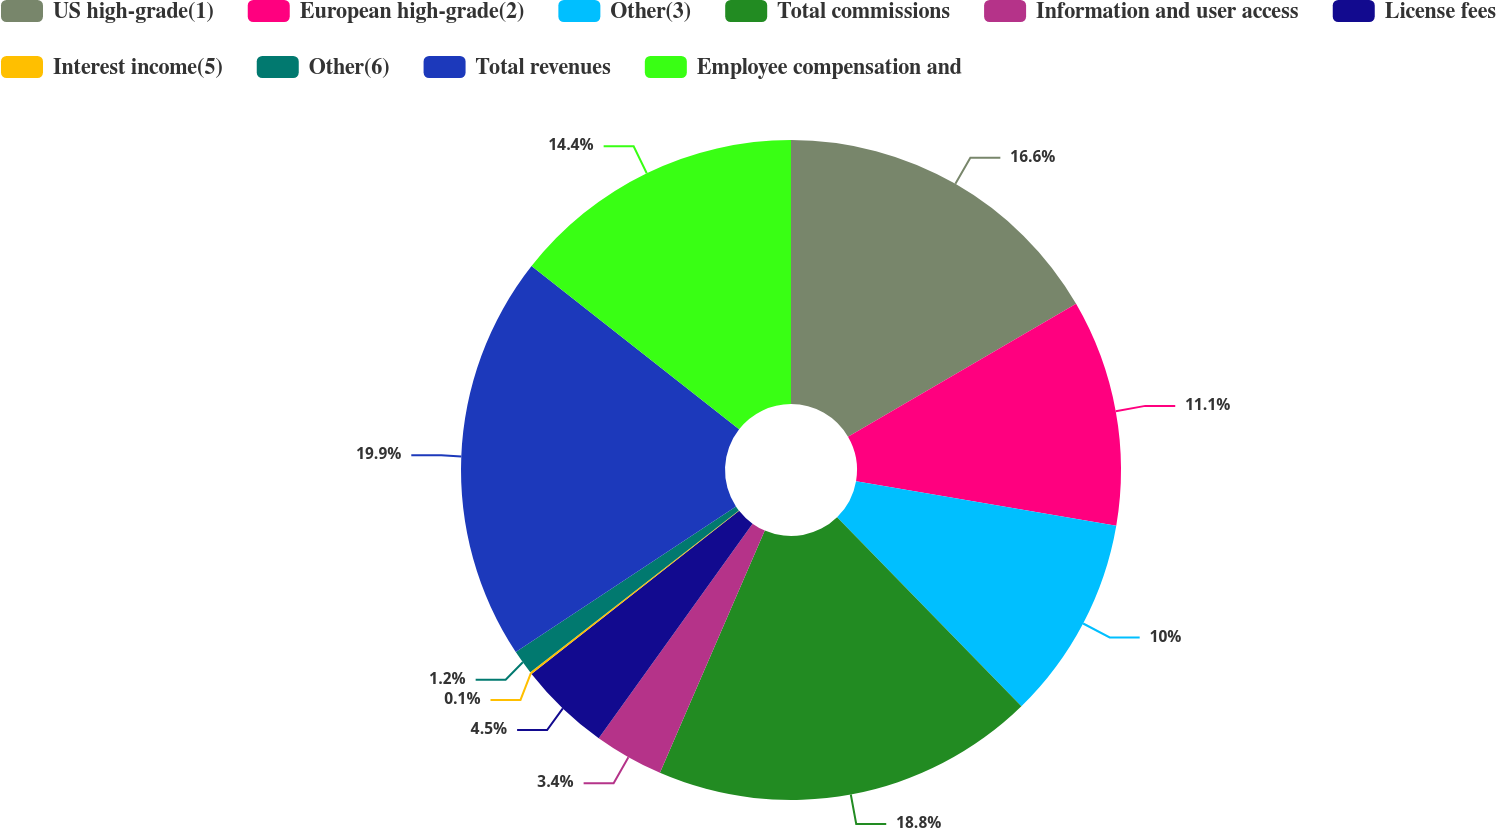Convert chart to OTSL. <chart><loc_0><loc_0><loc_500><loc_500><pie_chart><fcel>US high-grade(1)<fcel>European high-grade(2)<fcel>Other(3)<fcel>Total commissions<fcel>Information and user access<fcel>License fees<fcel>Interest income(5)<fcel>Other(6)<fcel>Total revenues<fcel>Employee compensation and<nl><fcel>16.6%<fcel>11.1%<fcel>10.0%<fcel>18.8%<fcel>3.4%<fcel>4.5%<fcel>0.1%<fcel>1.2%<fcel>19.9%<fcel>14.4%<nl></chart> 